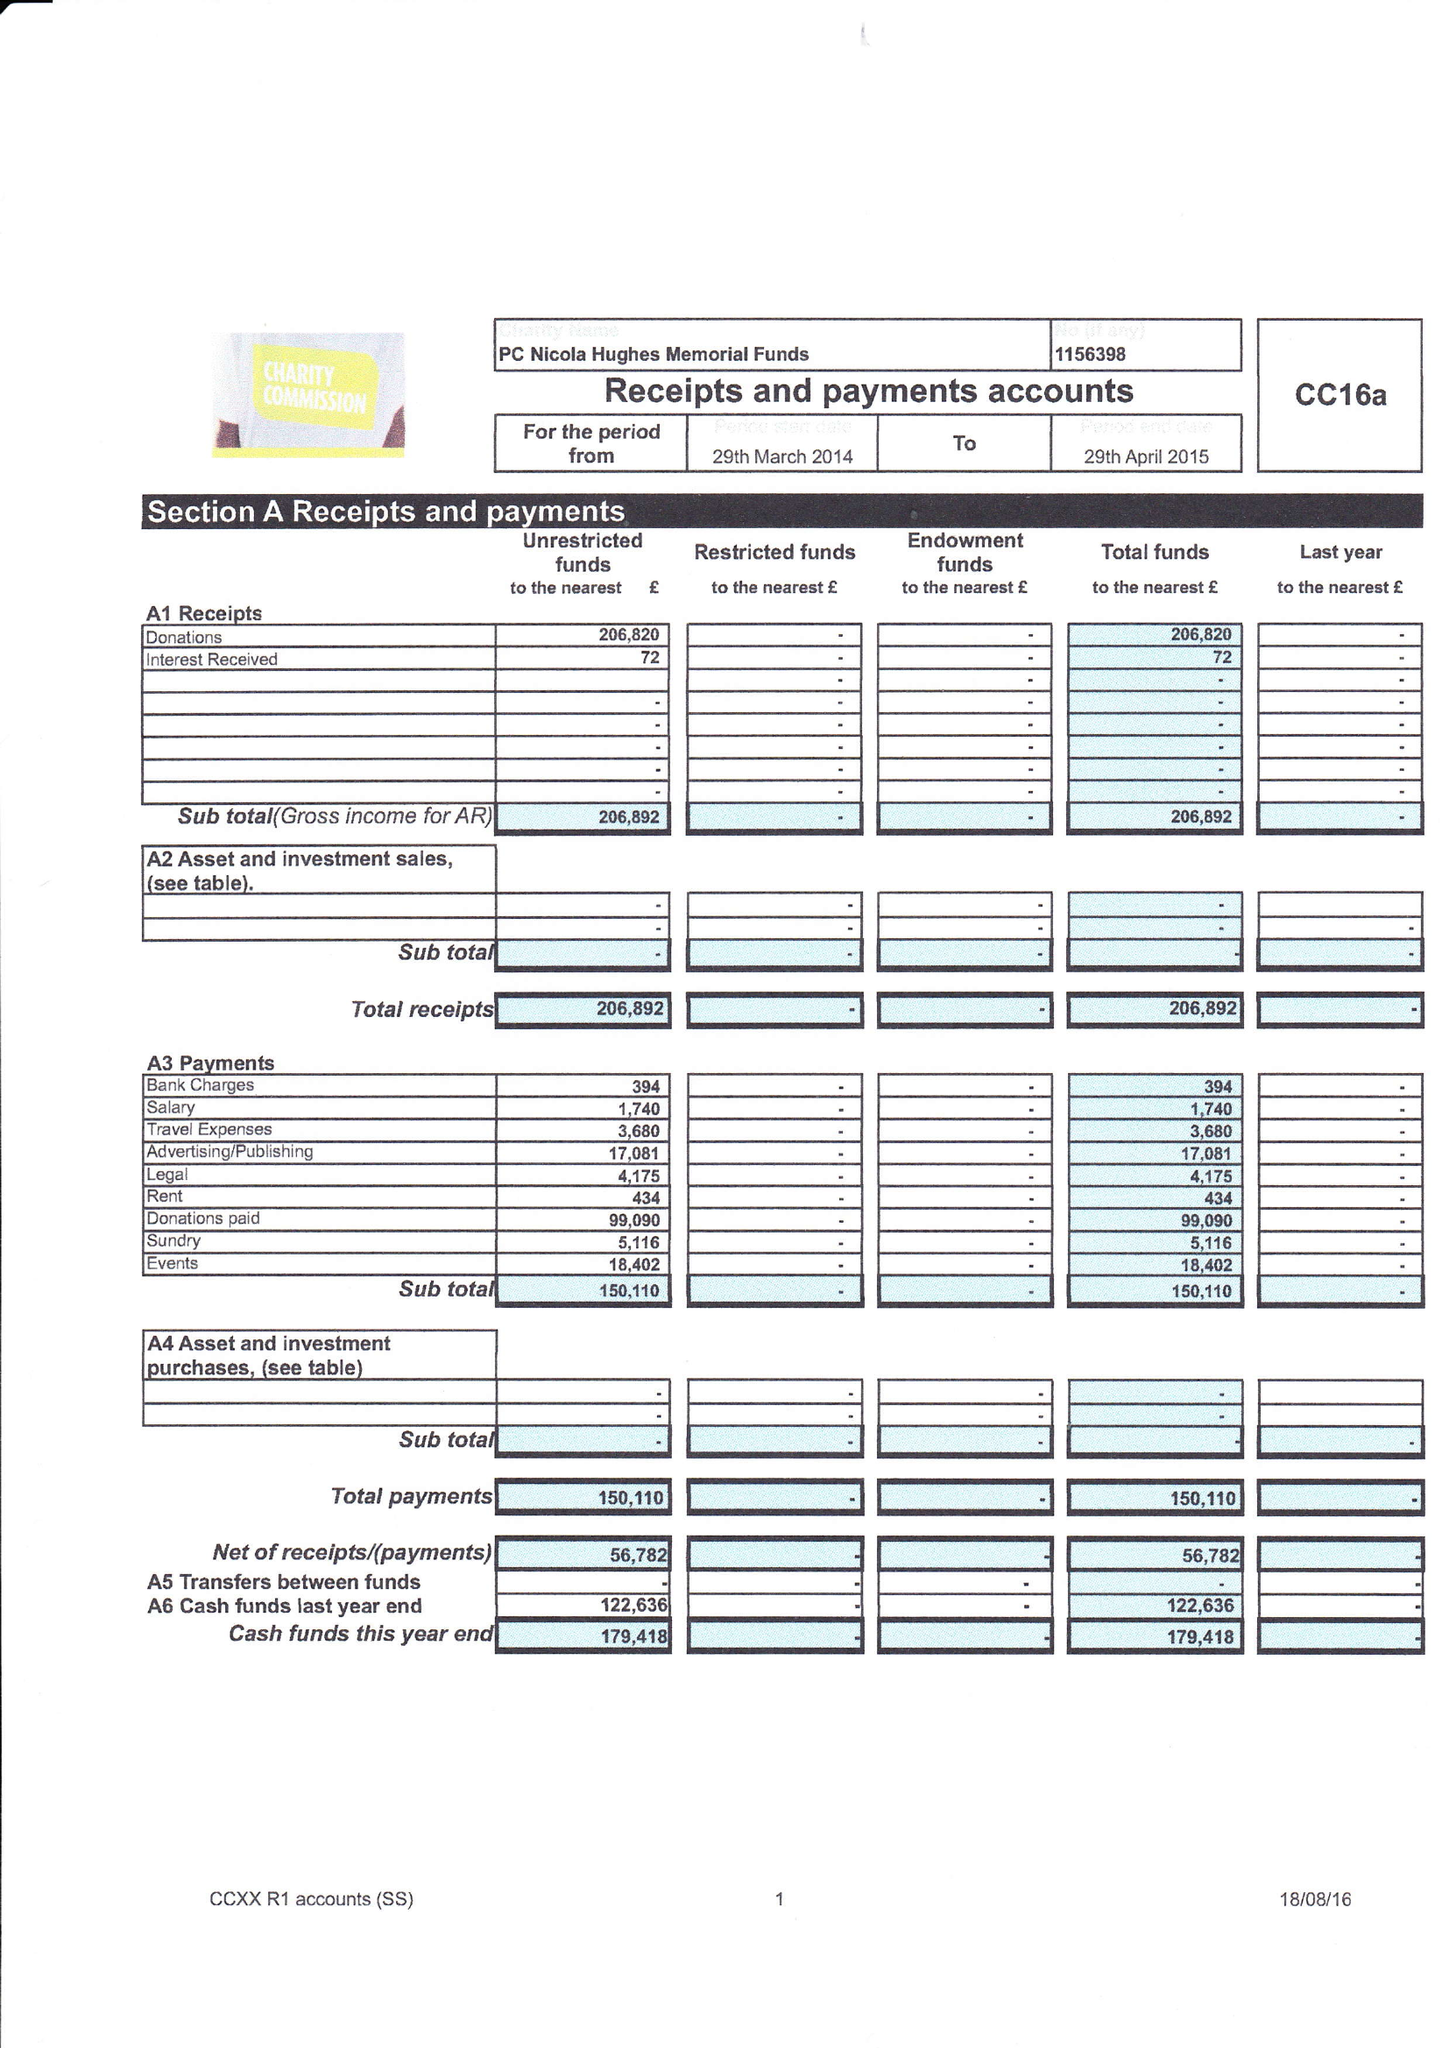What is the value for the charity_name?
Answer the question using a single word or phrase. Pc Nicola Hughes Memorial Fund 